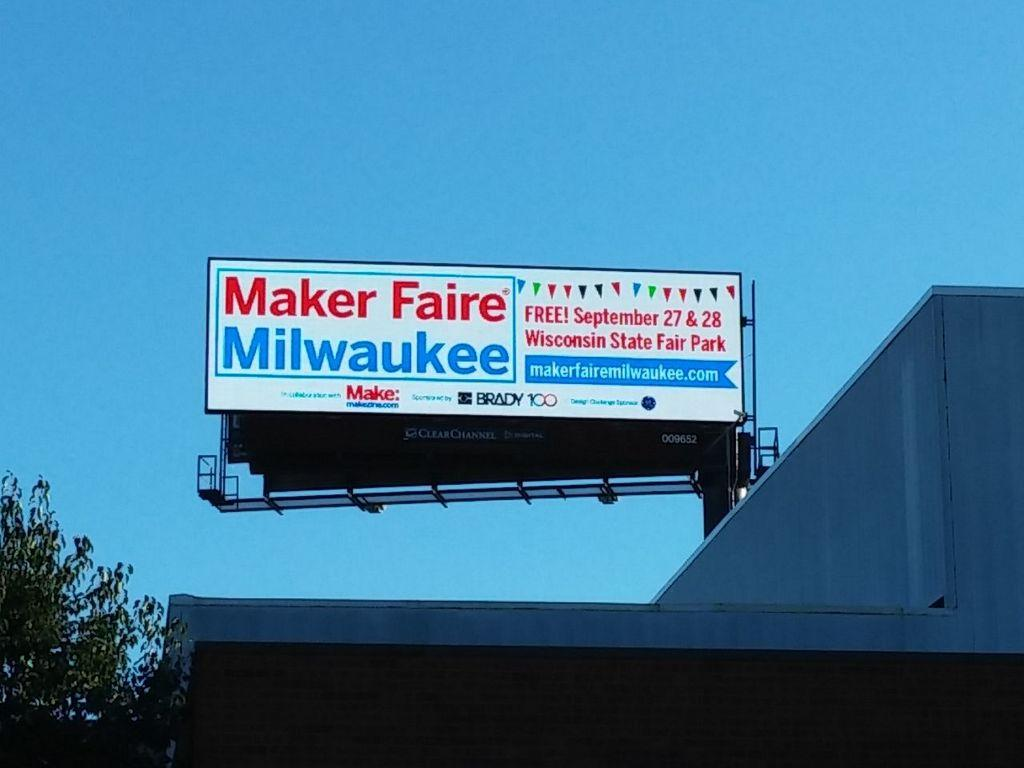Provide a one-sentence caption for the provided image. A sign advertising a free fair in Milwaukee. 